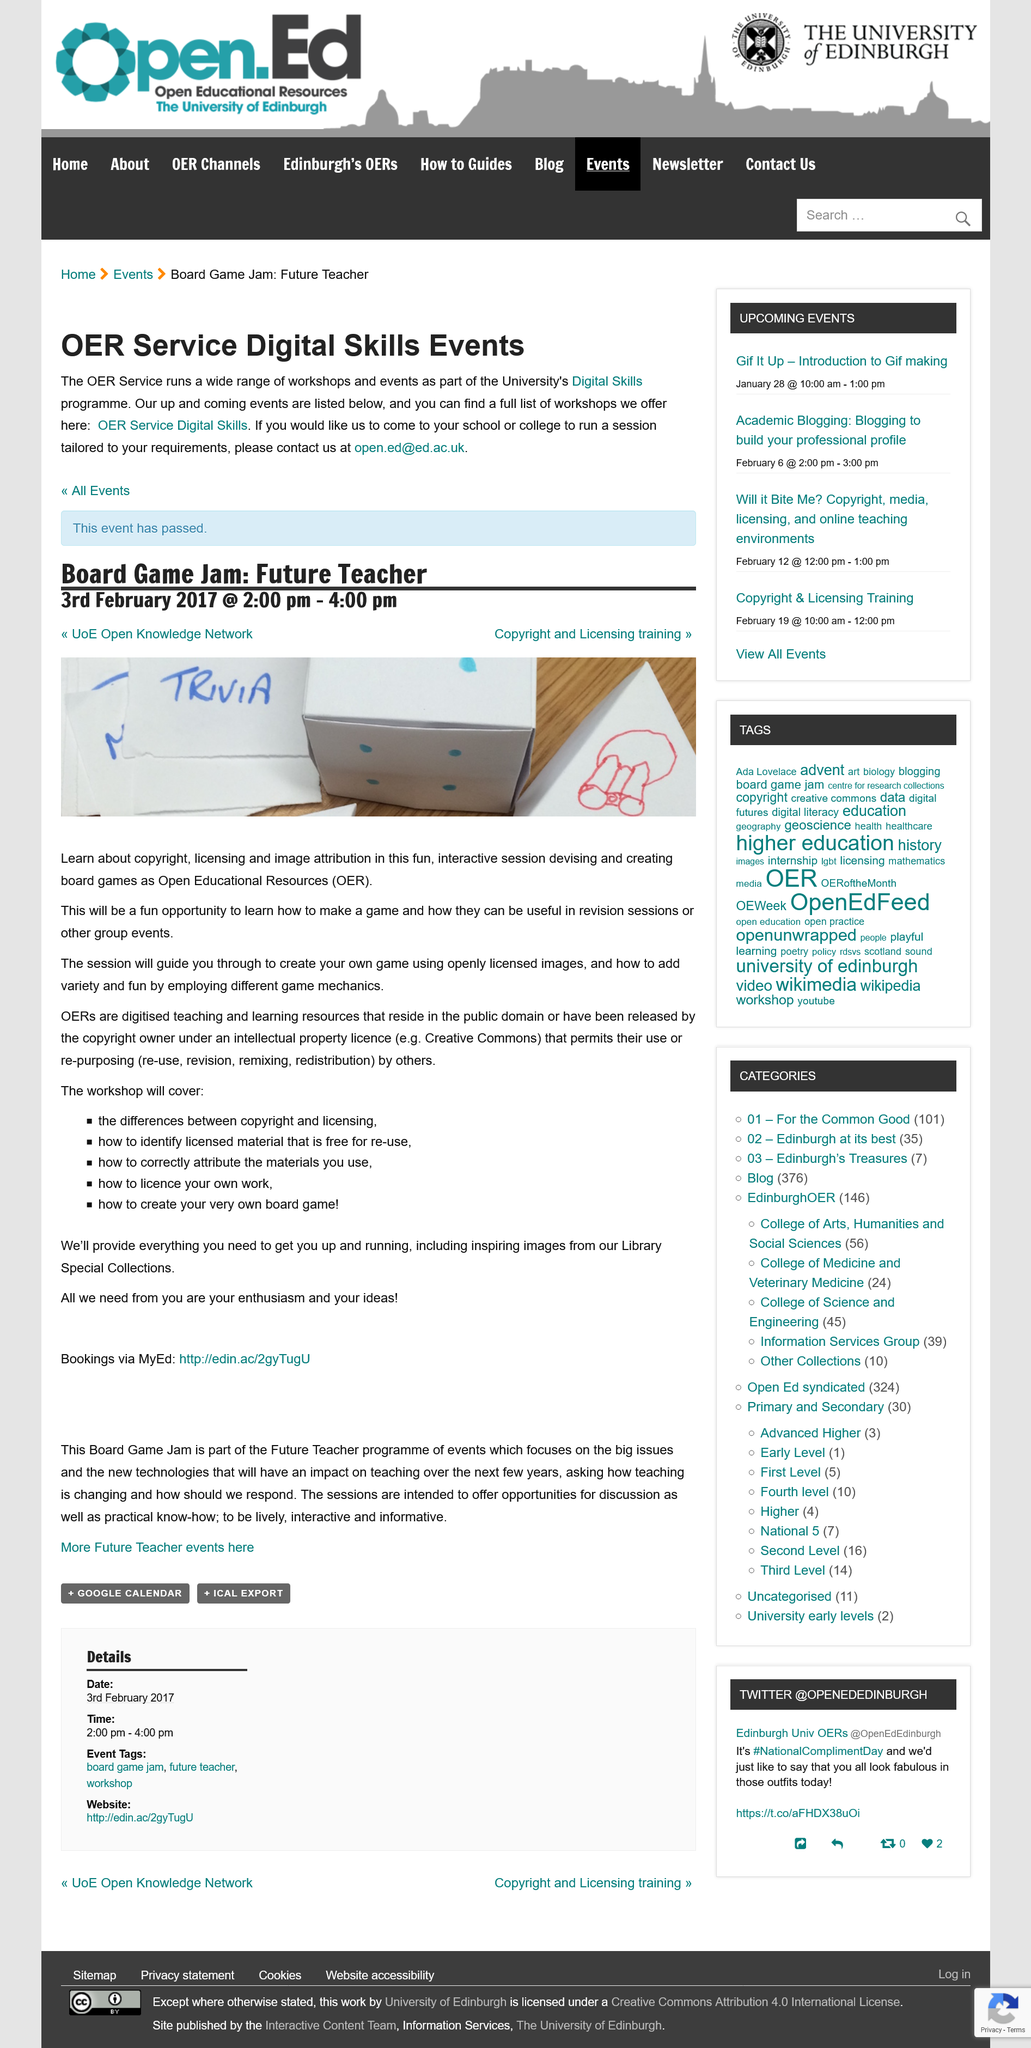Mention a couple of crucial points in this snapshot. This workshop helps users create board games. This workshop takes place between the hours of 2:00 pm and 4:00 pm. 